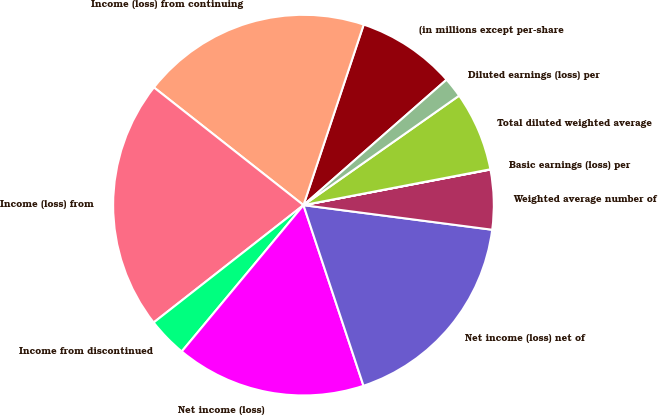<chart> <loc_0><loc_0><loc_500><loc_500><pie_chart><fcel>(in millions except per-share<fcel>Income (loss) from continuing<fcel>Income (loss) from<fcel>Income from discontinued<fcel>Net income (loss)<fcel>Net income (loss) net of<fcel>Weighted average number of<fcel>Basic earnings (loss) per<fcel>Total diluted weighted average<fcel>Diluted earnings (loss) per<nl><fcel>8.42%<fcel>19.51%<fcel>21.19%<fcel>3.38%<fcel>16.15%<fcel>17.83%<fcel>5.06%<fcel>0.02%<fcel>6.74%<fcel>1.7%<nl></chart> 